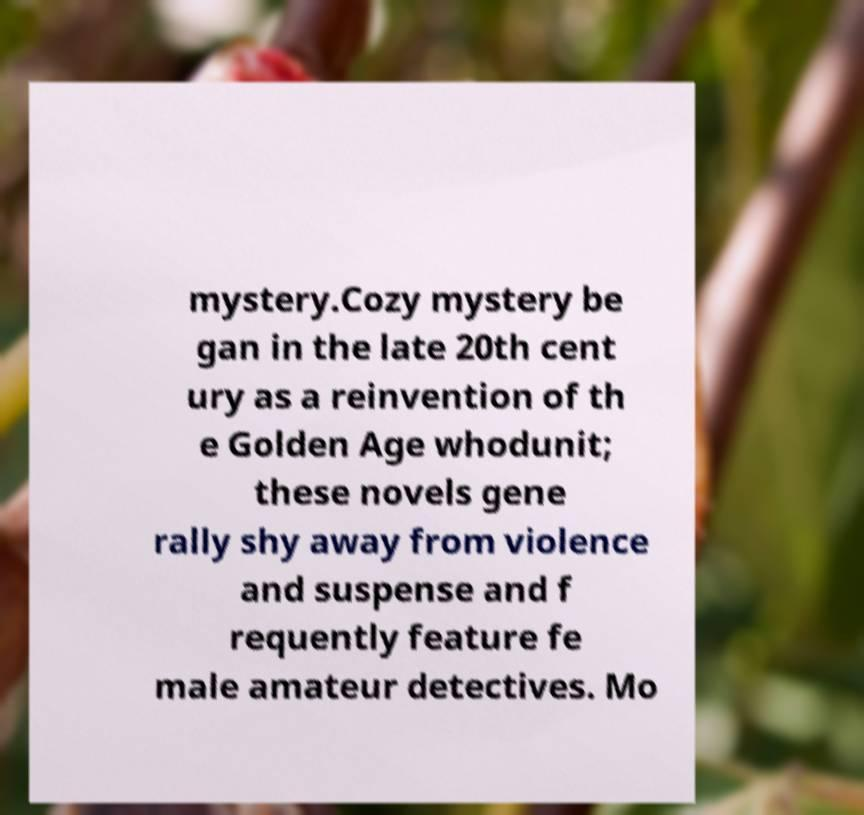Please read and relay the text visible in this image. What does it say? mystery.Cozy mystery be gan in the late 20th cent ury as a reinvention of th e Golden Age whodunit; these novels gene rally shy away from violence and suspense and f requently feature fe male amateur detectives. Mo 